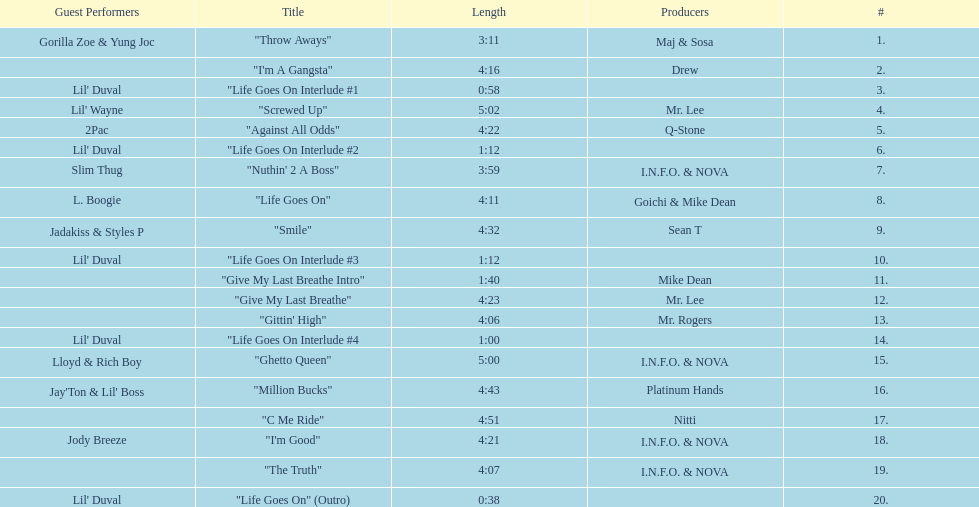How many tunes are there on trae's "life goes on" album? 20. Parse the table in full. {'header': ['Guest Performers', 'Title', 'Length', 'Producers', '#'], 'rows': [['Gorilla Zoe & Yung Joc', '"Throw Aways"', '3:11', 'Maj & Sosa', '1.'], ['', '"I\'m A Gangsta"', '4:16', 'Drew', '2.'], ["Lil' Duval", '"Life Goes On Interlude #1', '0:58', '', '3.'], ["Lil' Wayne", '"Screwed Up"', '5:02', 'Mr. Lee', '4.'], ['2Pac', '"Against All Odds"', '4:22', 'Q-Stone', '5.'], ["Lil' Duval", '"Life Goes On Interlude #2', '1:12', '', '6.'], ['Slim Thug', '"Nuthin\' 2 A Boss"', '3:59', 'I.N.F.O. & NOVA', '7.'], ['L. Boogie', '"Life Goes On"', '4:11', 'Goichi & Mike Dean', '8.'], ['Jadakiss & Styles P', '"Smile"', '4:32', 'Sean T', '9.'], ["Lil' Duval", '"Life Goes On Interlude #3', '1:12', '', '10.'], ['', '"Give My Last Breathe Intro"', '1:40', 'Mike Dean', '11.'], ['', '"Give My Last Breathe"', '4:23', 'Mr. Lee', '12.'], ['', '"Gittin\' High"', '4:06', 'Mr. Rogers', '13.'], ["Lil' Duval", '"Life Goes On Interlude #4', '1:00', '', '14.'], ['Lloyd & Rich Boy', '"Ghetto Queen"', '5:00', 'I.N.F.O. & NOVA', '15.'], ["Jay'Ton & Lil' Boss", '"Million Bucks"', '4:43', 'Platinum Hands', '16.'], ['', '"C Me Ride"', '4:51', 'Nitti', '17.'], ['Jody Breeze', '"I\'m Good"', '4:21', 'I.N.F.O. & NOVA', '18.'], ['', '"The Truth"', '4:07', 'I.N.F.O. & NOVA', '19.'], ["Lil' Duval", '"Life Goes On" (Outro)', '0:38', '', '20.']]} 